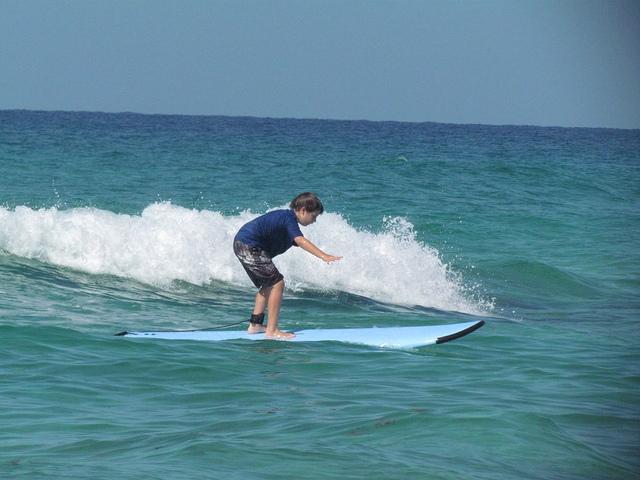Are they in a lake or on the ocean?
Quick response, please. Ocean. Is there a shark visible?
Answer briefly. No. What is the main color the kid is wearing?
Write a very short answer. Blue. What color are his swim trunks?
Answer briefly. Black. How many shirts can be seen?
Be succinct. 1. What is the kid riding one?
Answer briefly. Surfboard. 